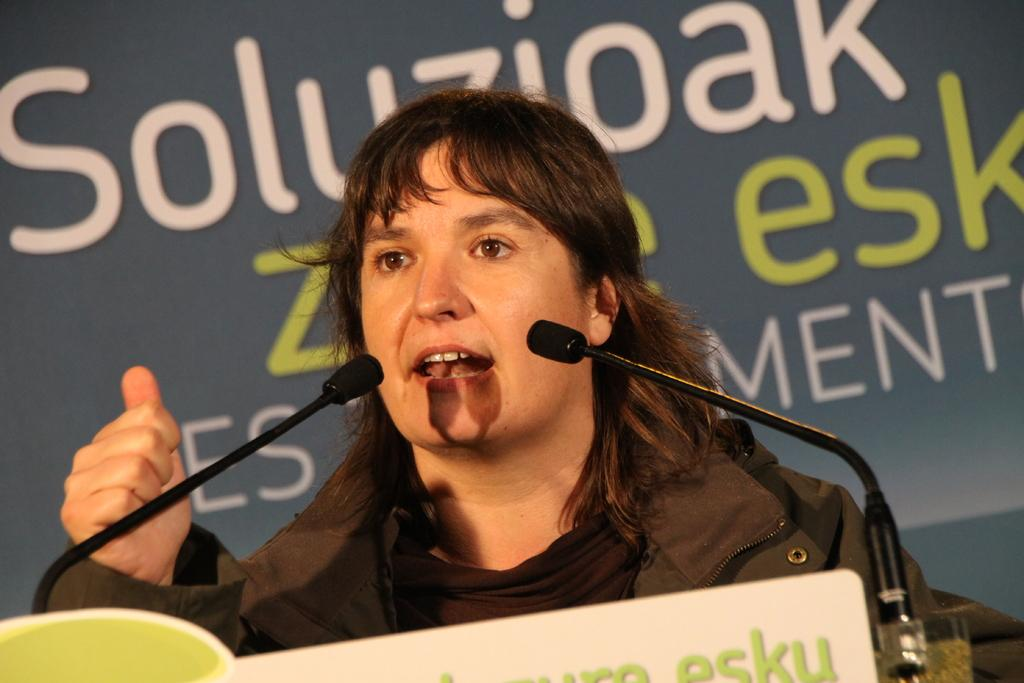Who or what is in the image? There is a person in the image. What objects are in front of the person? Microphones are present in front of the person. What can be seen in the background of the image? There is text visible in the background of the image. What type of liquid is being poured from the hat in the image? There is no hat or liquid present in the image. 